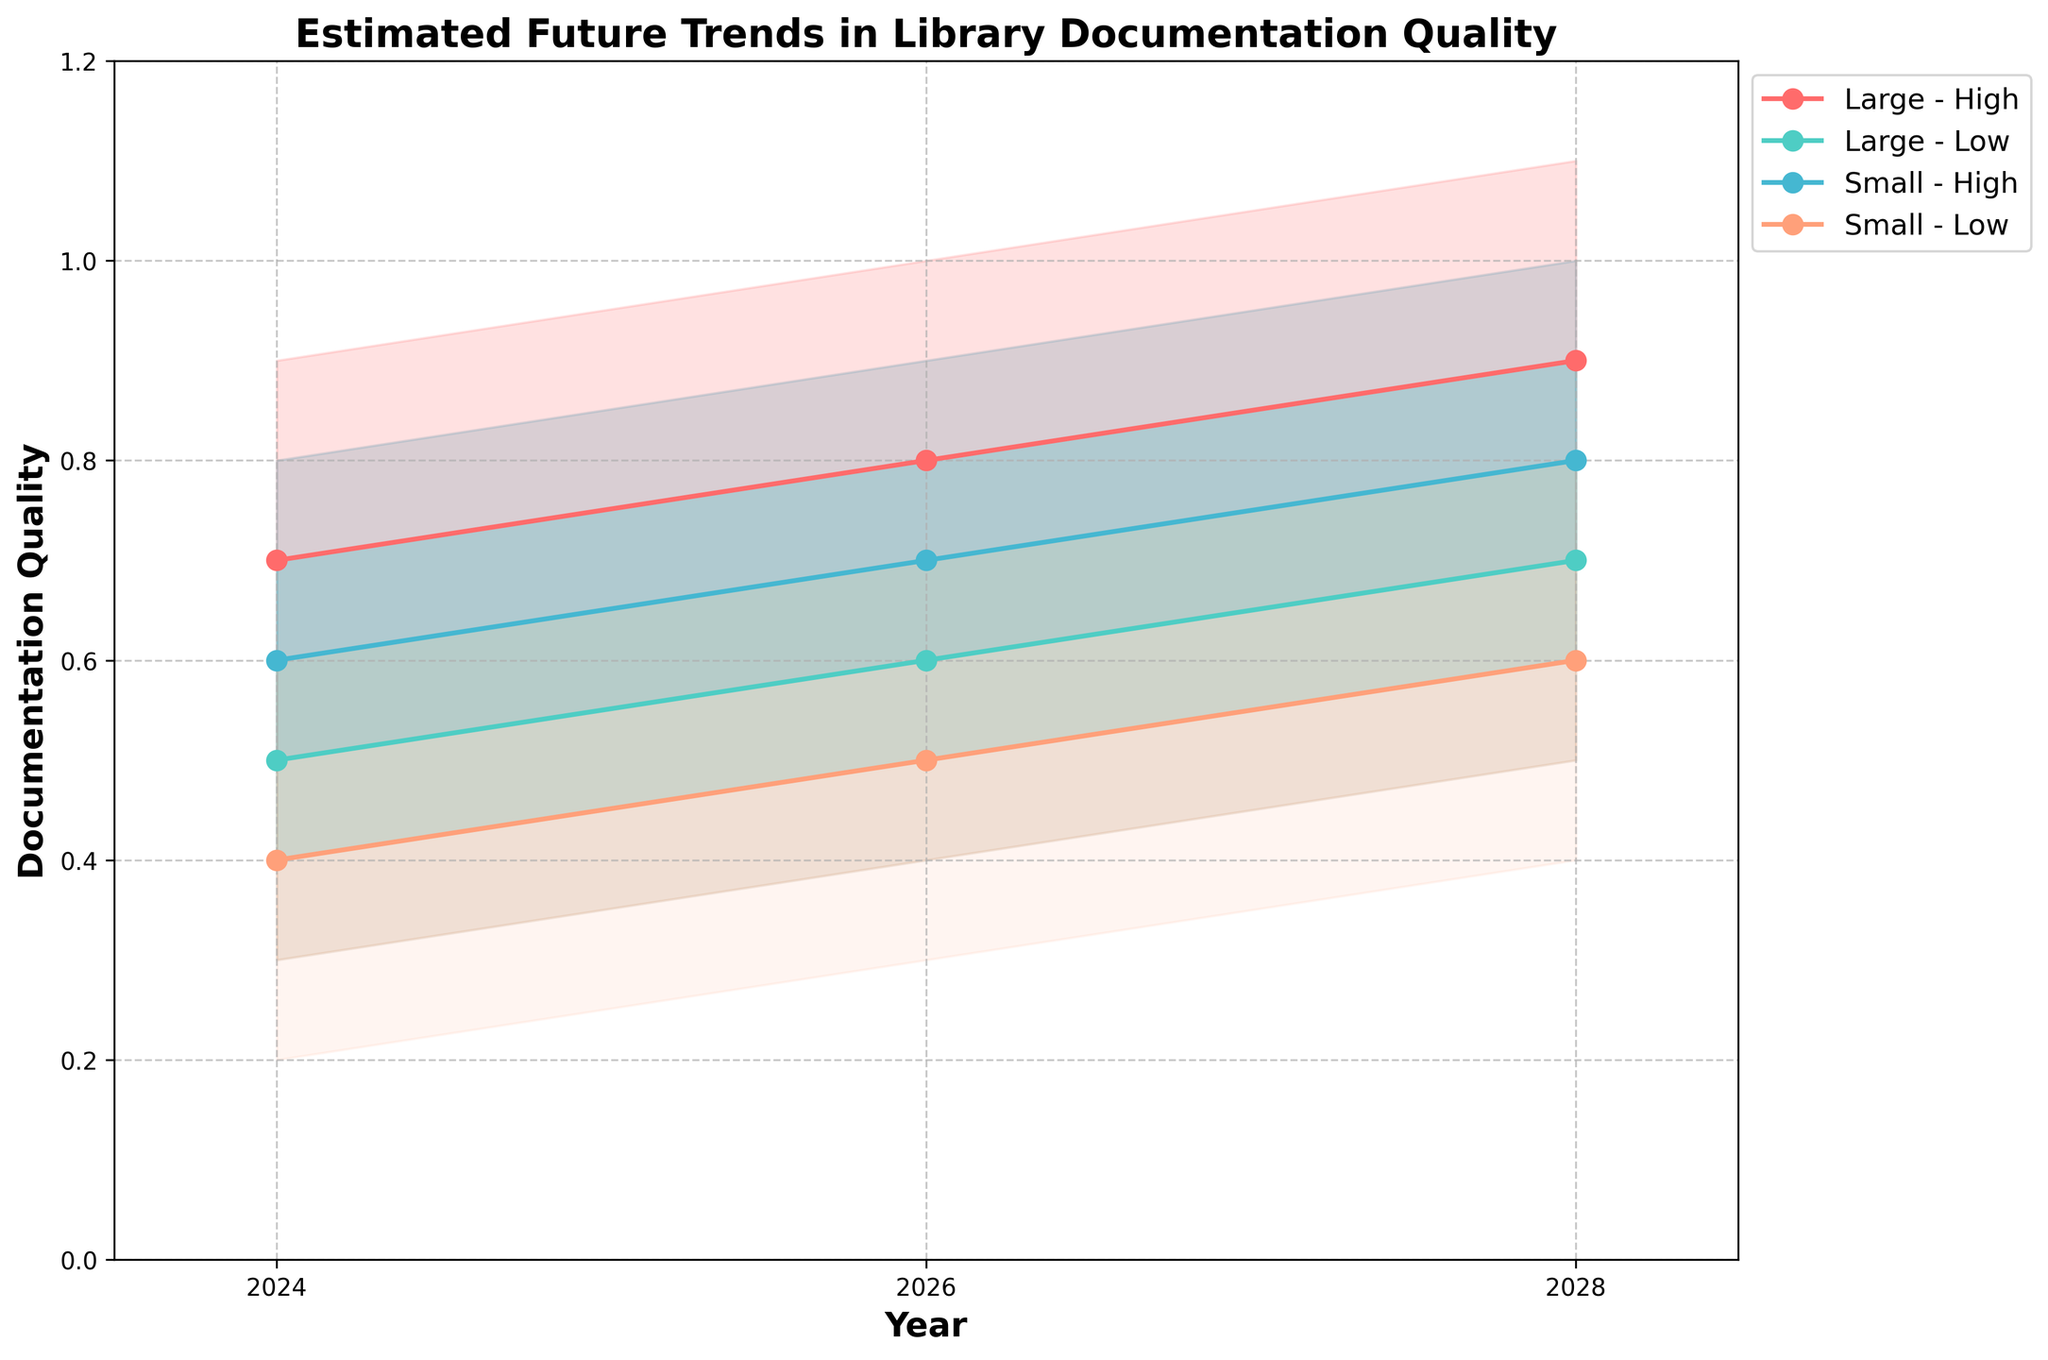What is the title of the chart? Look at the top section of the chart, where the title typically resides. The chart's title describes the overall content or objective of the visual representation.
Answer: Estimated Future Trends in Library Documentation Quality How does the documentation quality trend for Small-Low communities change from 2024 to 2028? Identify the plot corresponding to Small-Low communities and observe the MidEstimate line from 2024 to 2028.
Answer: It increases from 0.4 to 0.6 Which community has the highest documentation quality estimate in 2028? Compare the MidEstimate points for all communities in 2028.
Answer: Large-High How do the mid-estimates for Small-High and Large-Low communities compare in 2026? Compare the MidEstimate values for Small-High and Large-Low communities in 2026.
Answer: Small-High is 0.7 and Large-Low is 0.6 What is the range of documentation quality estimates for Small-High communities in 2024? Identify the estimates range between LowEstimate and HighEstimate for Small-High communities in 2024.
Answer: 0.4 to 0.8 Which community shows the smallest change in mid-estimate documentation quality from 2024 to 2028? Calculate the differences in MidEstimate values from 2024 to 2028 for all communities and find the smallest difference.
Answer: Large-Low By how much does the average documentation quality estimate (using MidEstimate) for Large communities increase from 2024 to 2028? Calculate the average MidEstimate for Large communities in 2024 and in 2028, then determine the difference.
Answer: The increase is 0.2 (from 0.6 to 0.8) How does the uncertainty in documentation quality for Small-Low community in 2028 compare to its uncertainty in 2024? Compare the width between LowEstimate and HighEstimate for Small-Low community in 2024 and 2028, respectively.
Answer: The uncertainty range in 2028 is larger (0.4 to 0.8) compared to 2024 (0.3 to 0.6) Which community has the steepest upward trend in documentation quality from 2024 to 2028? Determine the community with the largest increase in MidEstimate values from 2024 to 2028.
Answer: Large-High What are the high-mid estimates for Large-Low community in 2026? Identify the HighMidEstimate value for the Large-Low community in 2026.
Answer: 0.7 